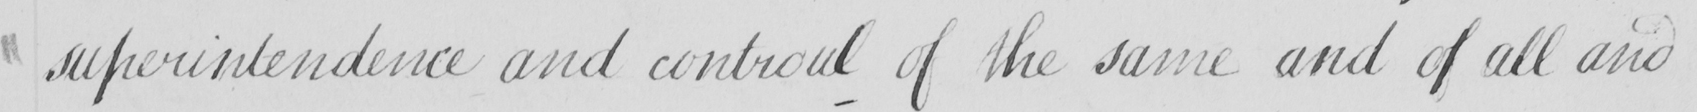What is written in this line of handwriting? superintendence and control of the same and of all and 